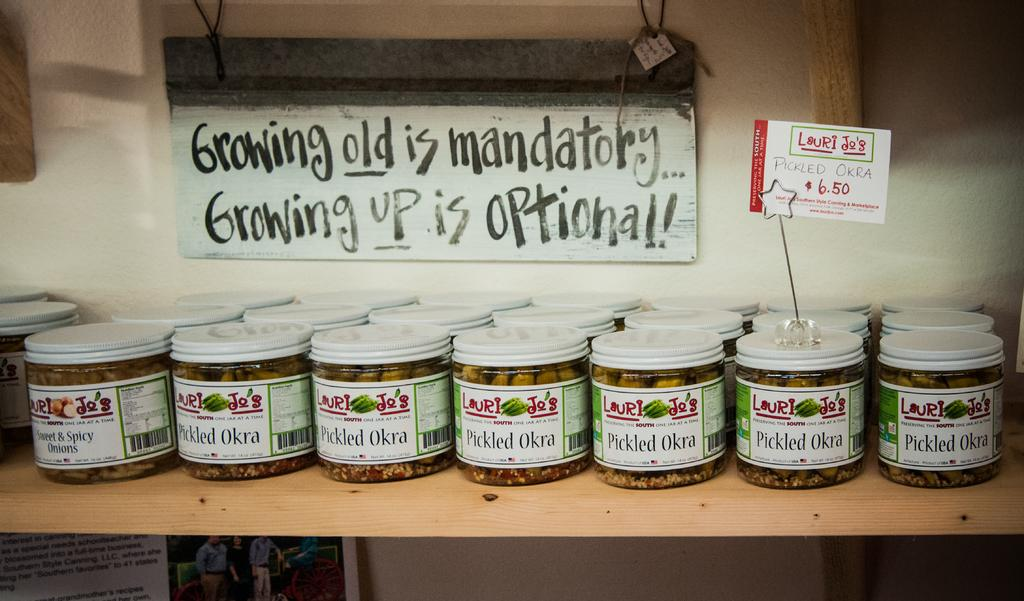What type of containers are visible in the image? There are glass bottles in the image. Where are the glass bottles placed? The glass bottles are on a wooden rack. What can be seen in the background of the image? There is a white color board in the background of the image. How is the white color board attached to the wall? The white color board is attached to the wall. What is the color of the wall in the image? The wall is in white color. How many girls are holding the vase in the image? There are no girls or vases present in the image. 